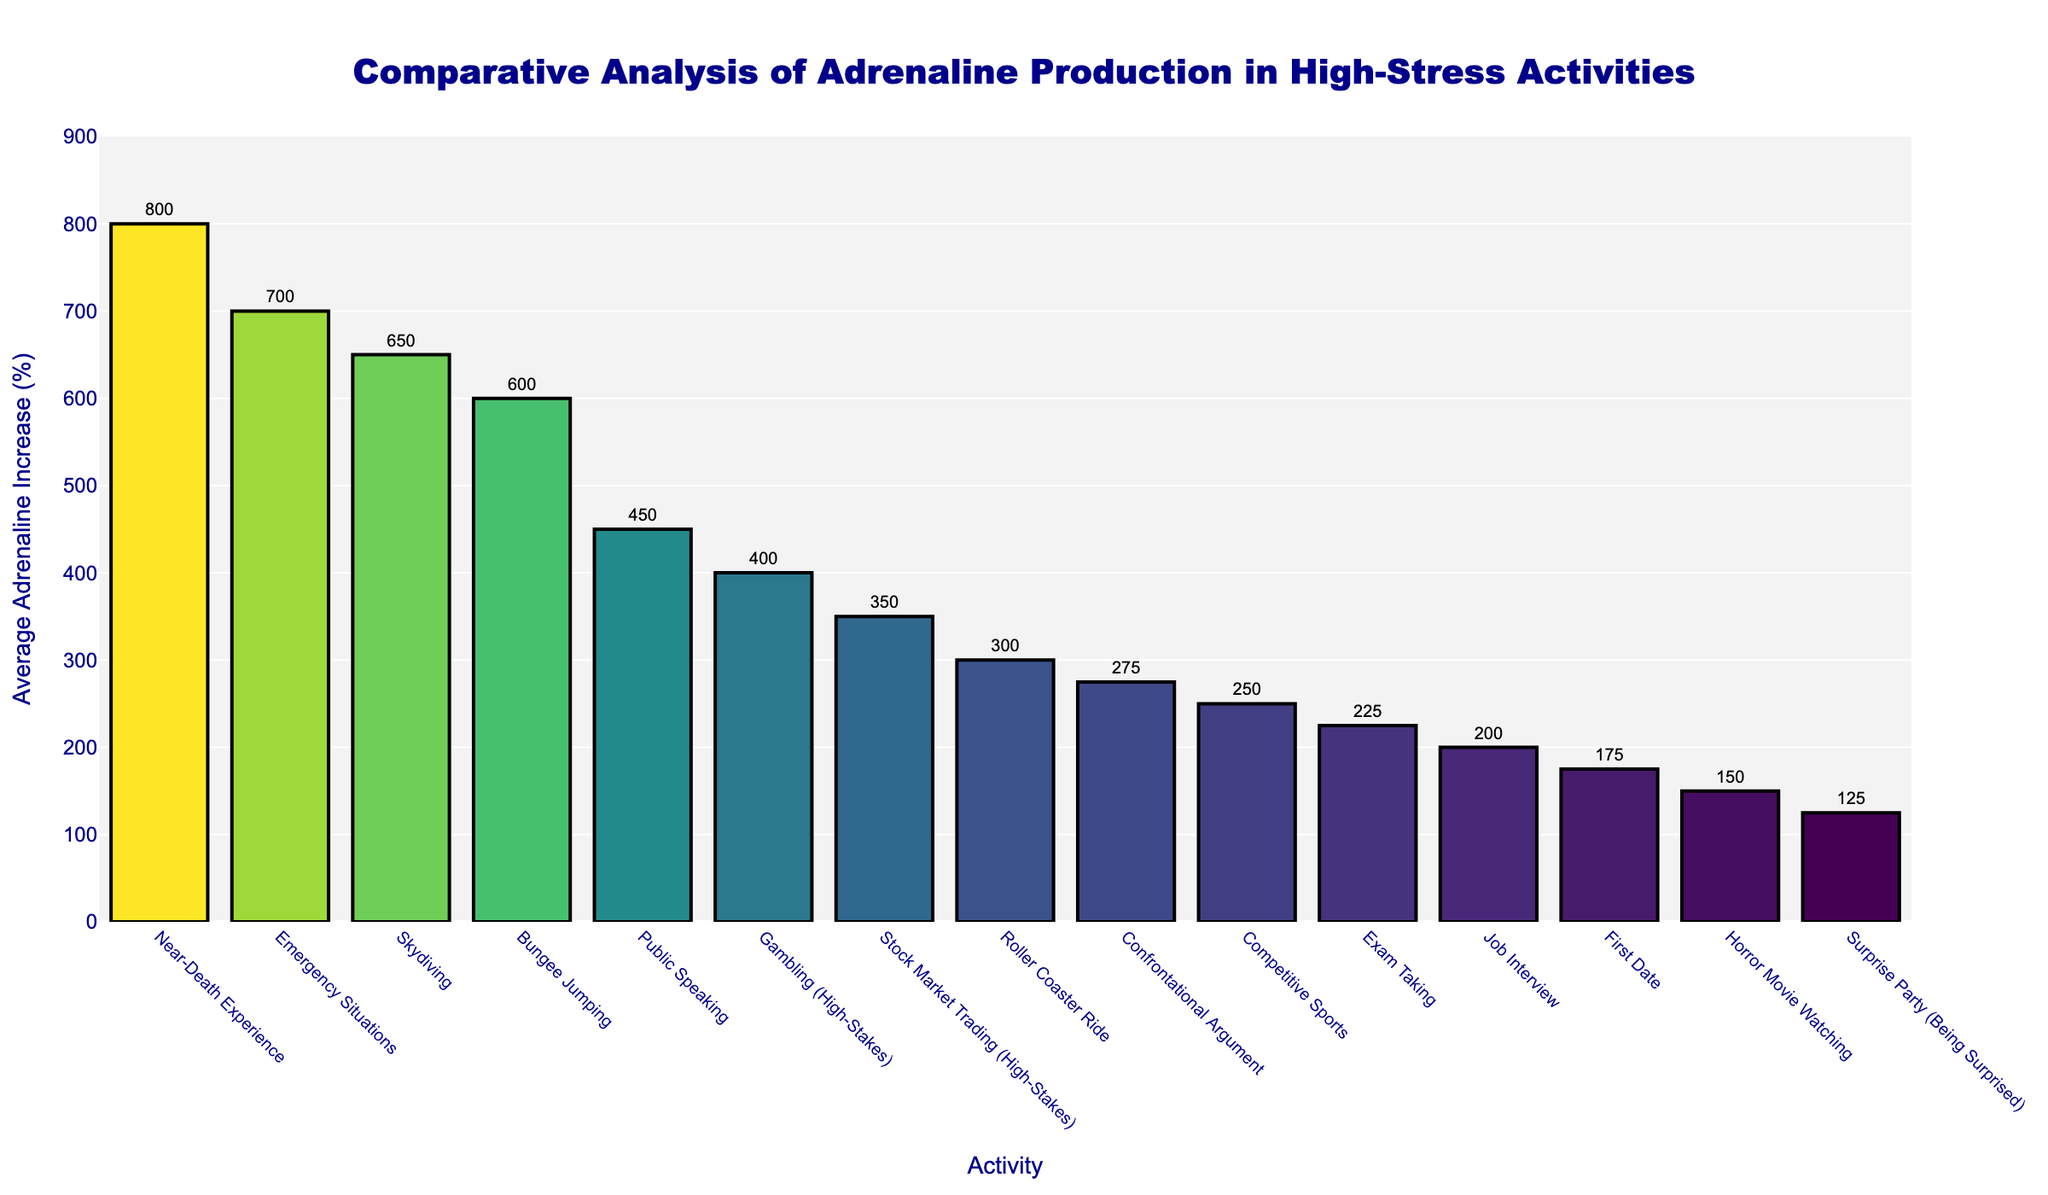Which activity leads to the highest average adrenaline increase? Look at the bar chart and identify the tallest bar. The activity corresponding to the tallest bar has the highest average adrenaline increase. Here, it's 'Near-Death Experience' with 800%.
Answer: Near-Death Experience Which activity leads to the lowest average adrenaline increase? Look at the bar chart and identify the shortest bar. The activity corresponding to the shortest bar has the lowest average adrenaline increase. Here, it's 'Surprise Party (Being Surprised)' with 125%.
Answer: Surprise Party (Being Surprised) How much higher is the average adrenaline increase during Emergency Situations compared to Roller Coaster Ride? Subtract the average adrenaline increase of Roller Coaster Ride (300%) from Emergency Situations (700%). 700% - 300% = 400%.
Answer: 400% What is the combined average adrenaline increase for Public Speaking, Job Interview, and Exam Taking? Add the average adrenaline increase for Public Speaking (450%), Job Interview (200%), and Exam Taking (225%). 450% + 200% + 225% = 875%.
Answer: 875% Among Skydiving and Bungee Jumping, which activity leads to a higher average adrenaline increase, and by how much? Compare the bars for Skydiving (650%) and Bungee Jumping (600%). Subtract the lower value from the higher value. 650% - 600% = 50%.
Answer: Skydiving, 50% What is the average adrenaline increase for Confrontational Argument and Gambling (High-Stakes)? Add the average adrenaline increase for Confrontational Argument (275%) and Gambling (High-Stakes) (400%), then divide by 2. (275% + 400%) / 2 = 337.5%.
Answer: 337.5% Which activity shows a greater adrenaline increase: Competitive Sports or Stock Market Trading (High-Stakes)? Compare the bars for Competitive Sports (250%) and Stock Market Trading (High-Stakes) (350%). The higher value is 350%.
Answer: Stock Market Trading (High-Stakes) What is the range of adrenaline increase percentages shown in the chart? Subtract the smallest value (Surprise Party (Being Surprised), 125%) from the largest value (Near-Death Experience, 800%). 800% - 125% = 675%.
Answer: 675% 